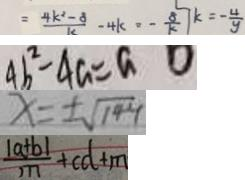<formula> <loc_0><loc_0><loc_500><loc_500>= \frac { 4 k ^ { 2 } - 8 } { k } - 4 k = - \frac { 8 } { k } \vert k = - \frac { 4 } { y } 
 4 b ^ { 2 } - 4 a = a 0 
 x = \pm \sqrt { 1 4 4 } 
 \frac { \vert a + b \vert } { n } + c d + m</formula> 